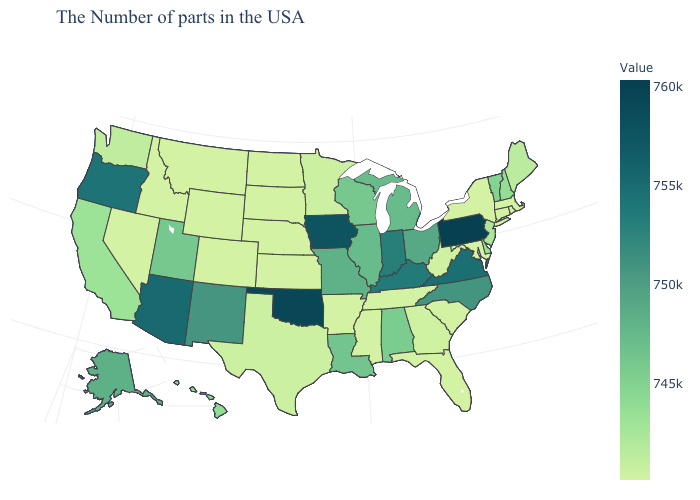Does Arizona have the highest value in the West?
Answer briefly. Yes. Does Arizona have a higher value than Oklahoma?
Keep it brief. No. Which states have the lowest value in the South?
Concise answer only. Maryland, South Carolina, Florida, Tennessee, Mississippi, Arkansas. Which states have the lowest value in the Northeast?
Short answer required. Massachusetts, Rhode Island, Connecticut, New York. Which states have the highest value in the USA?
Be succinct. Pennsylvania. Which states have the highest value in the USA?
Short answer required. Pennsylvania. Among the states that border Texas , does Oklahoma have the highest value?
Write a very short answer. Yes. 